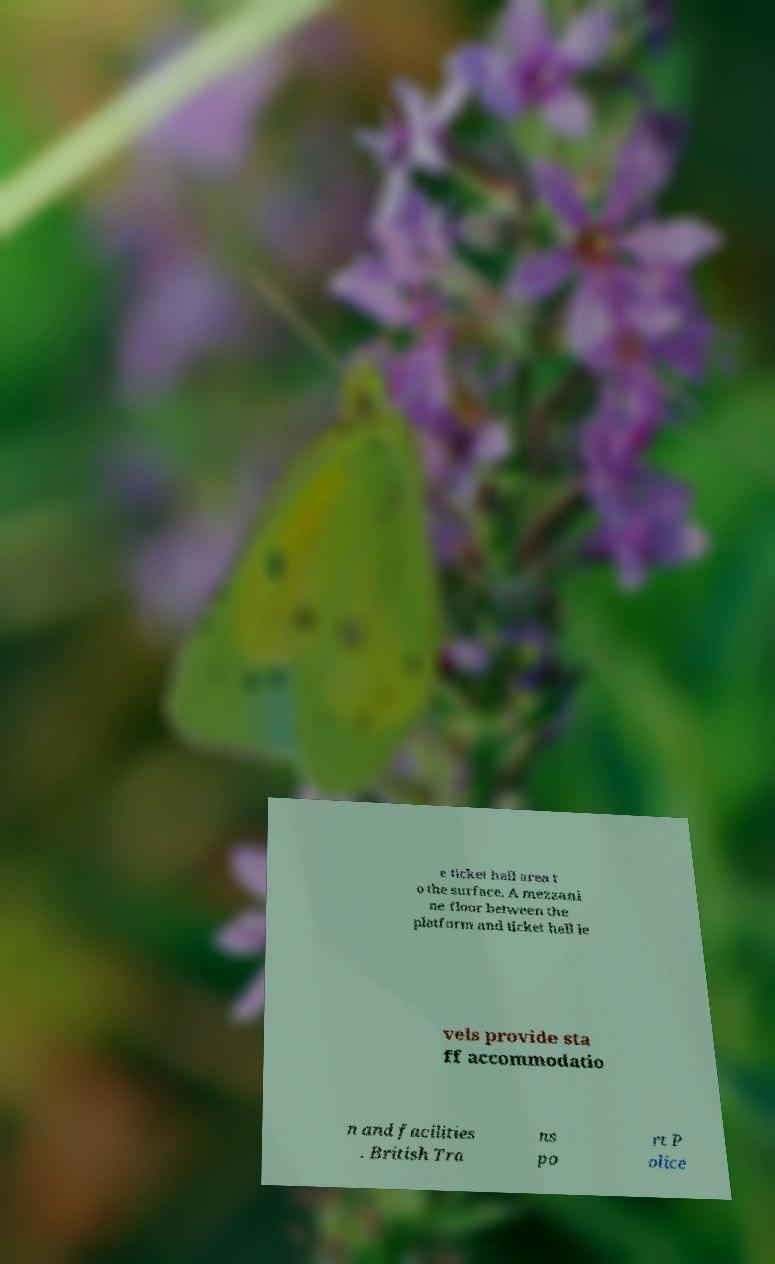Can you read and provide the text displayed in the image?This photo seems to have some interesting text. Can you extract and type it out for me? e ticket hall area t o the surface. A mezzani ne floor between the platform and ticket hall le vels provide sta ff accommodatio n and facilities . British Tra ns po rt P olice 